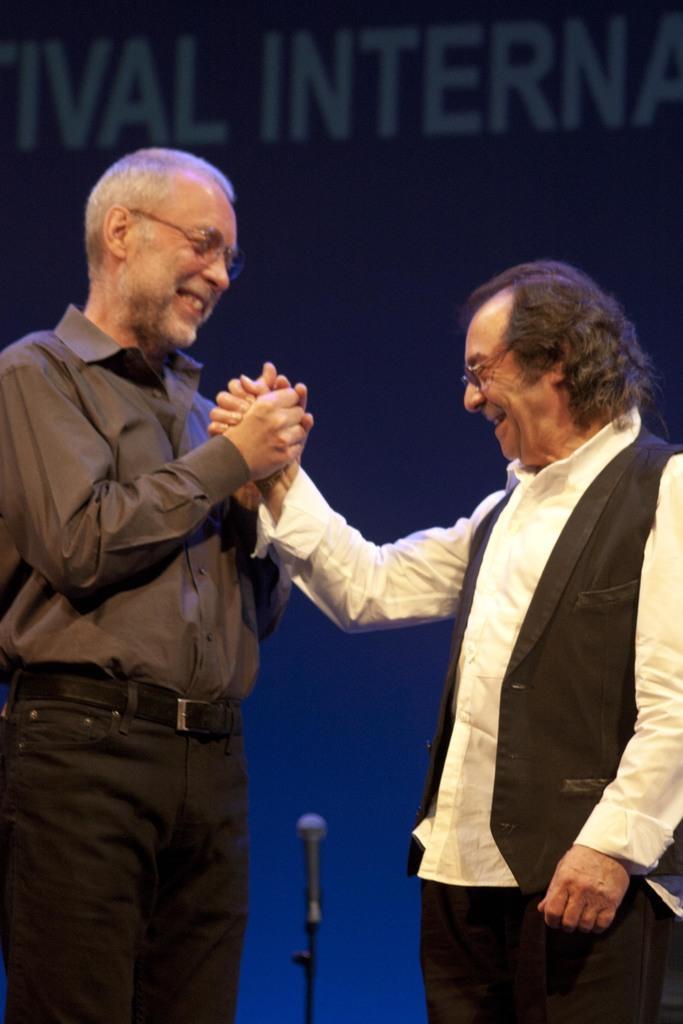Describe this image in one or two sentences. In this image I can see two persons standing, the person at right is wearing black blazer, white shirt and black pant and the person at left is wearing brown shirt, black pant. Background I can see a microphone and I can see blue color background. 